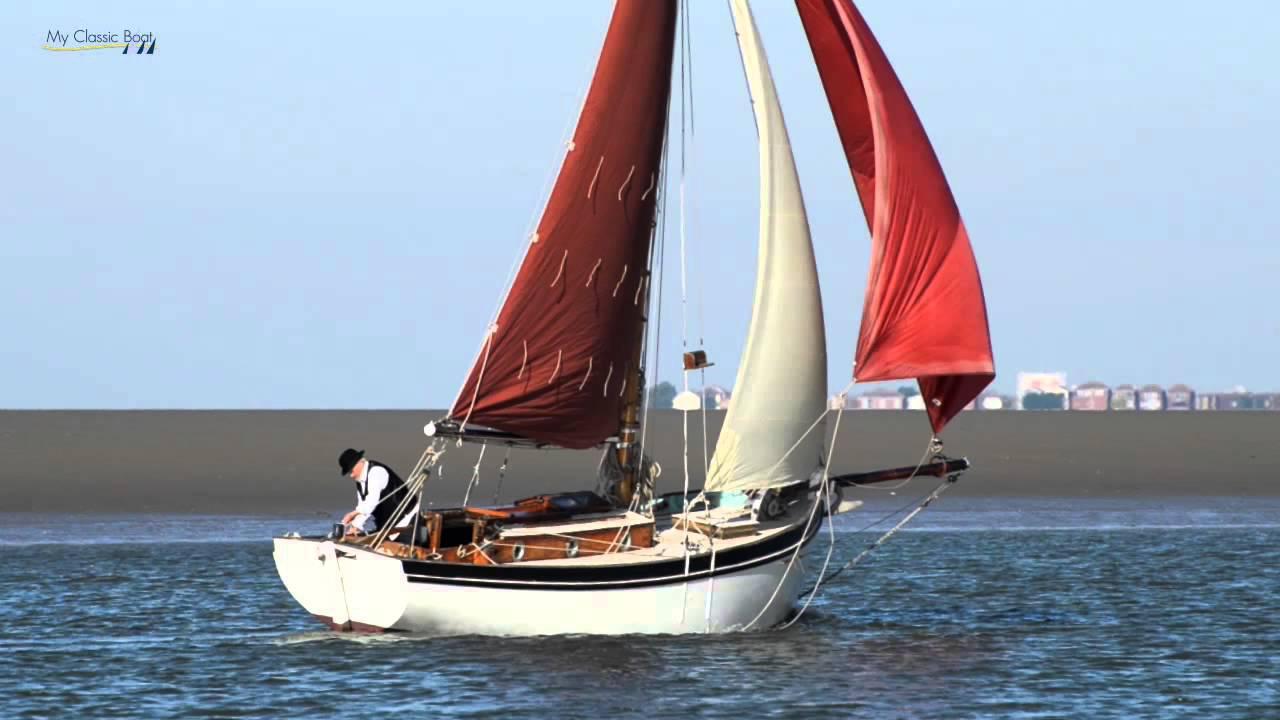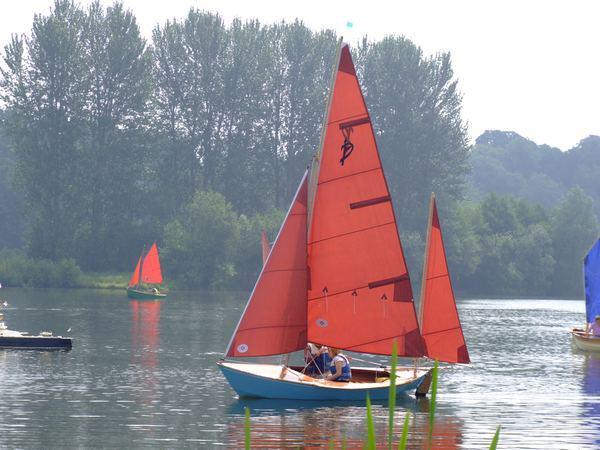The first image is the image on the left, the second image is the image on the right. Analyze the images presented: Is the assertion "in the right pic the nearest pic has three sails" valid? Answer yes or no. Yes. 